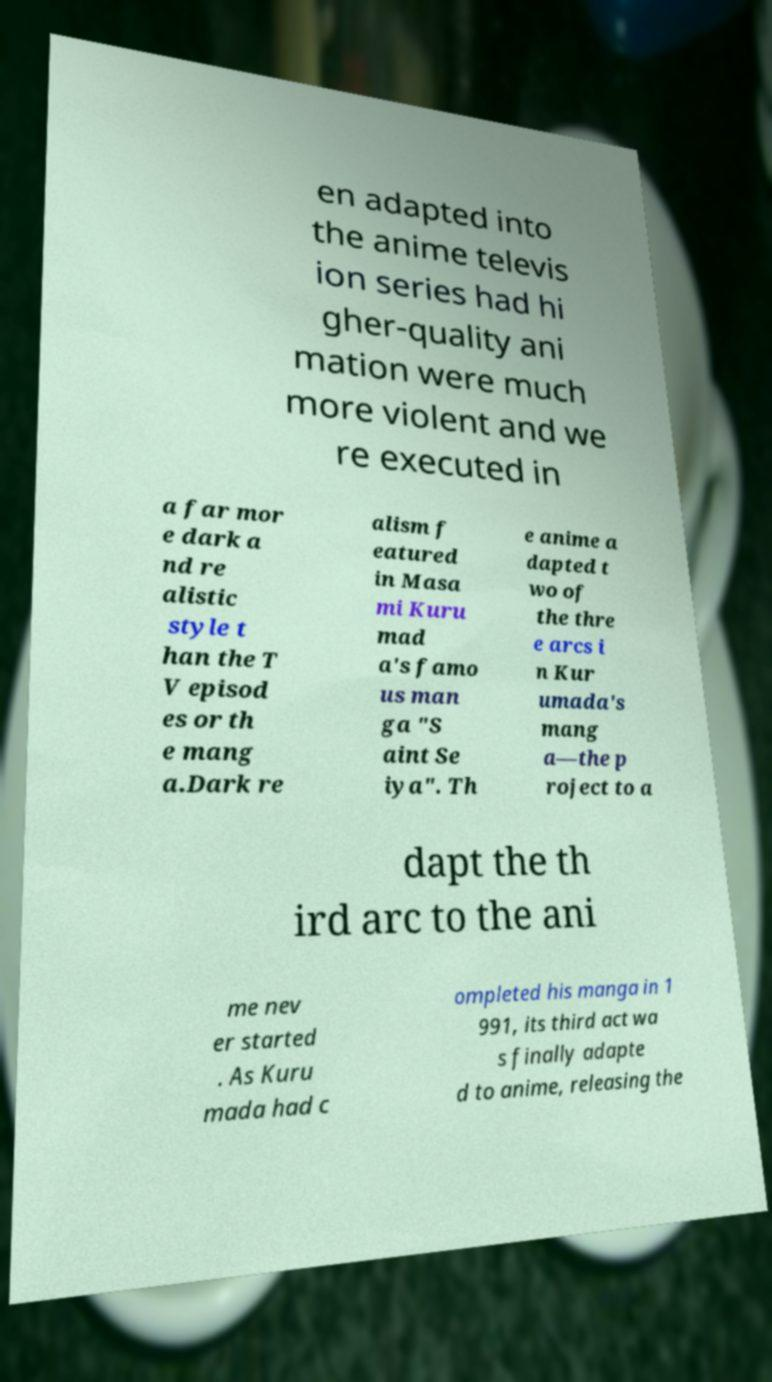Could you extract and type out the text from this image? en adapted into the anime televis ion series had hi gher-quality ani mation were much more violent and we re executed in a far mor e dark a nd re alistic style t han the T V episod es or th e mang a.Dark re alism f eatured in Masa mi Kuru mad a's famo us man ga "S aint Se iya". Th e anime a dapted t wo of the thre e arcs i n Kur umada's mang a—the p roject to a dapt the th ird arc to the ani me nev er started . As Kuru mada had c ompleted his manga in 1 991, its third act wa s finally adapte d to anime, releasing the 